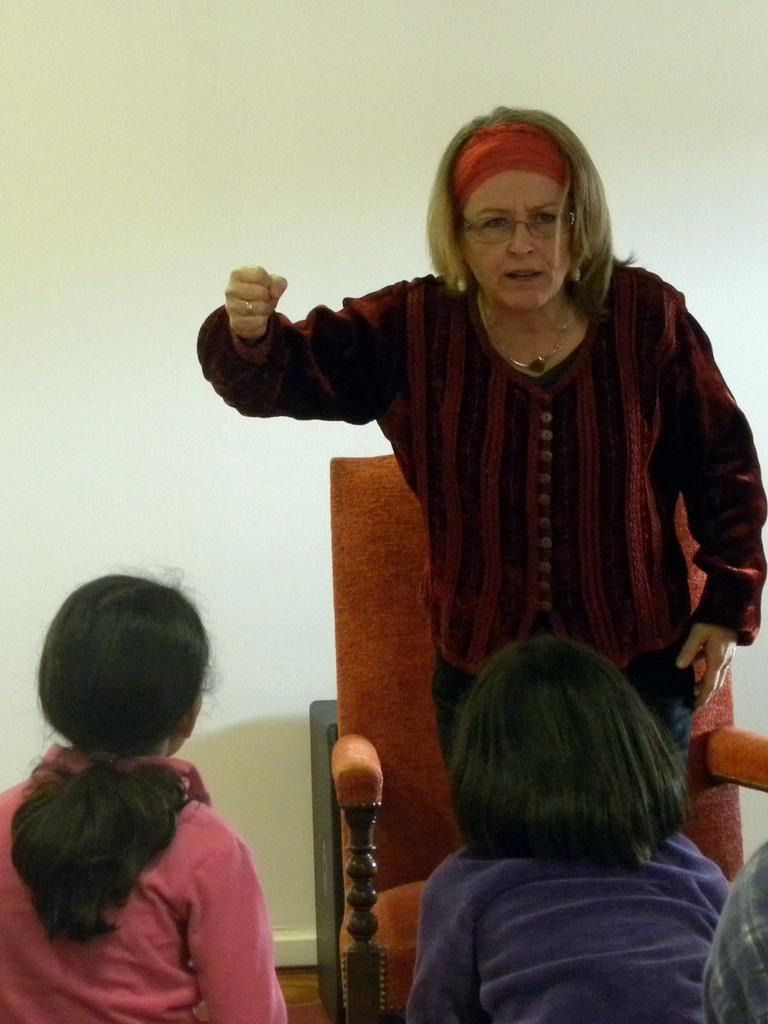How many girls are in the image? There are two girls in the image. Where are the girls located in the image? The girls are located towards the bottom of the image. Who else is present in the image besides the girls? There is a woman standing in the image. What can be seen behind the woman? There is a chair behind the woman. What is visible in the background of the image? There is a wall in the image. What type of mice can be seen playing in the middle of the image? There are no mice present in the image, and therefore no such activity can be observed. 